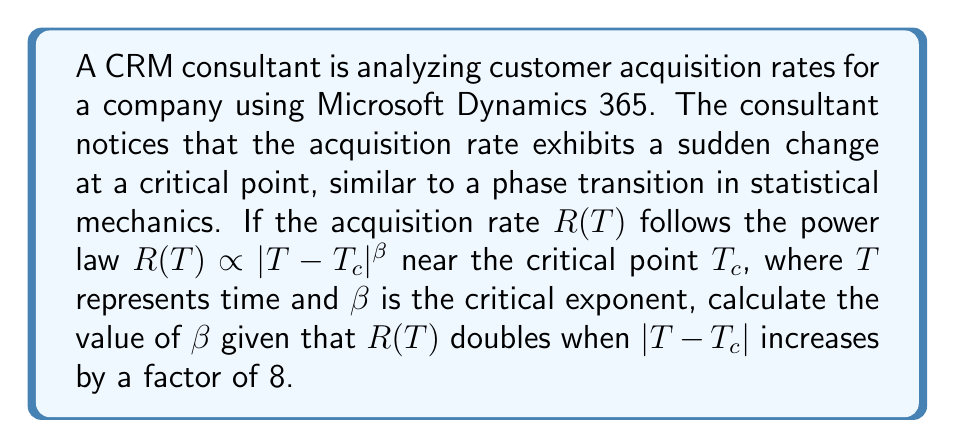Teach me how to tackle this problem. To solve this problem, we'll follow these steps:

1) The power law relationship is given by:
   $$R(T) \propto |T-T_c|^\beta$$

2) Let's consider two points: $(T_1, R_1)$ and $(T_2, R_2)$, where $R_2 = 2R_1$ and $|T_2-T_c| = 8|T_1-T_c|$.

3) We can write:
   $$\frac{R_2}{R_1} = \left(\frac{|T_2-T_c|}{|T_1-T_c|}\right)^\beta$$

4) Substituting the given values:
   $$2 = 8^\beta$$

5) Taking the logarithm of both sides:
   $$\log 2 = \beta \log 8$$

6) Solving for $\beta$:
   $$\beta = \frac{\log 2}{\log 8} = \frac{\log 2}{\log 2^3} = \frac{\log 2}{3\log 2} = \frac{1}{3}$$

Therefore, the critical exponent $\beta$ is $\frac{1}{3}$.
Answer: $\beta = \frac{1}{3}$ 